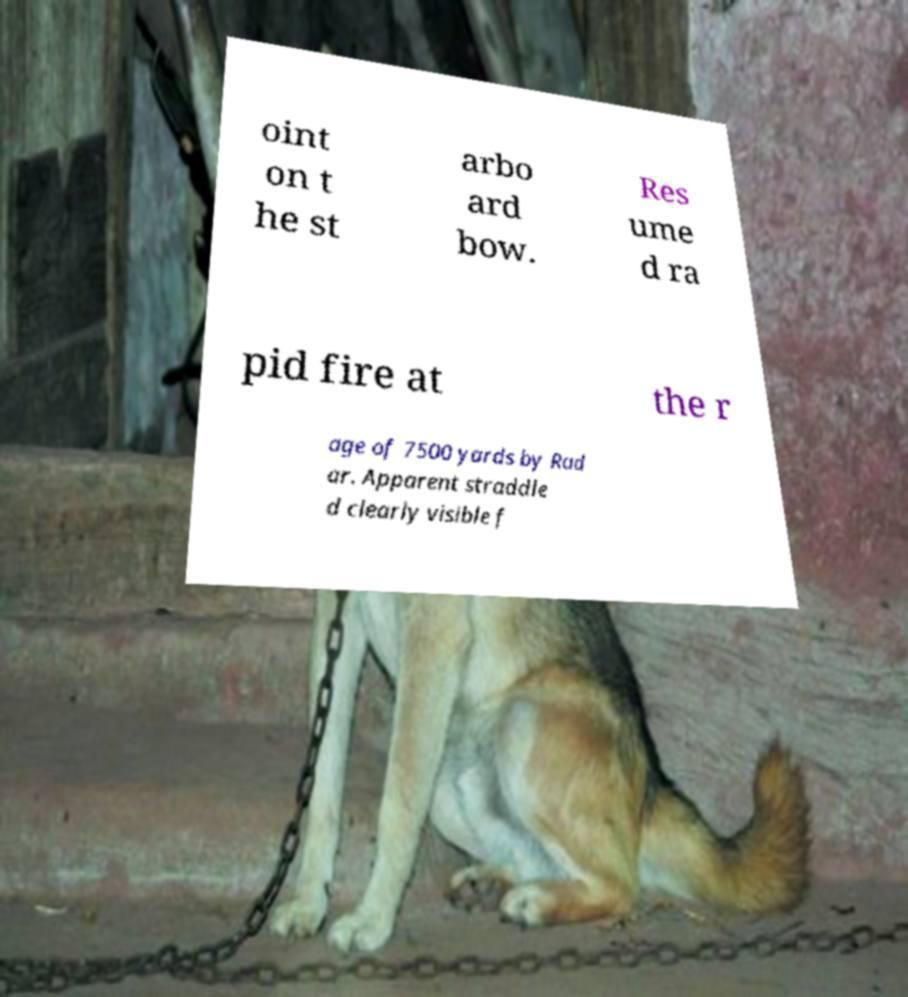There's text embedded in this image that I need extracted. Can you transcribe it verbatim? oint on t he st arbo ard bow. Res ume d ra pid fire at the r age of 7500 yards by Rad ar. Apparent straddle d clearly visible f 